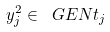<formula> <loc_0><loc_0><loc_500><loc_500>y _ { j } ^ { 2 } \in \ G E N { t _ { j } }</formula> 